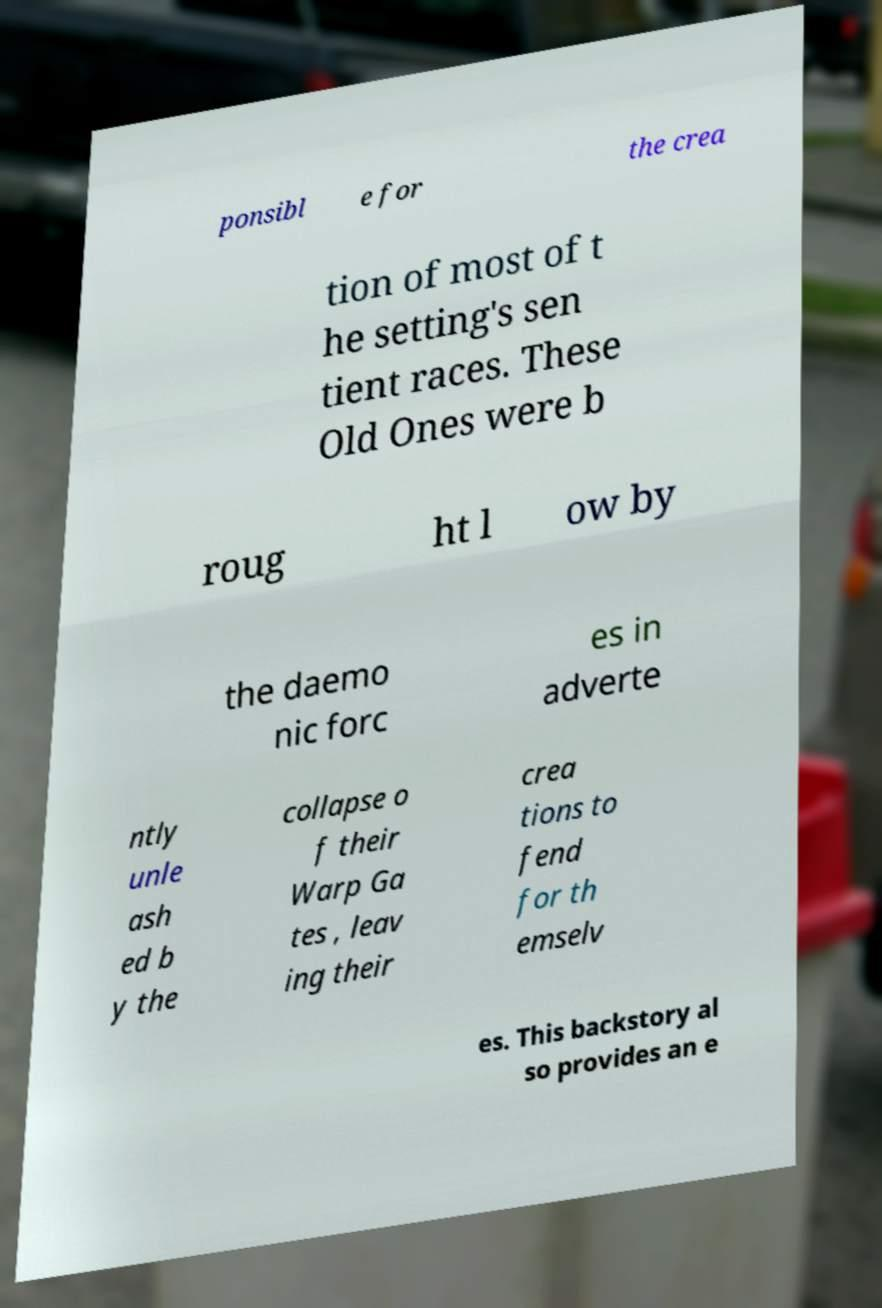Please identify and transcribe the text found in this image. ponsibl e for the crea tion of most of t he setting's sen tient races. These Old Ones were b roug ht l ow by the daemo nic forc es in adverte ntly unle ash ed b y the collapse o f their Warp Ga tes , leav ing their crea tions to fend for th emselv es. This backstory al so provides an e 